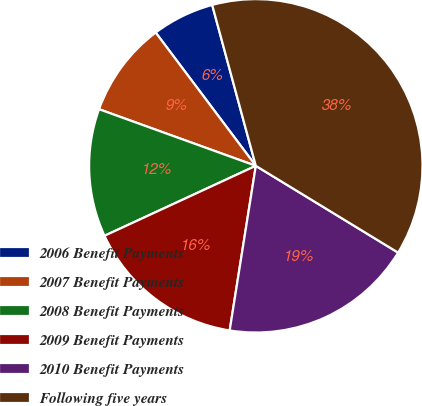Convert chart to OTSL. <chart><loc_0><loc_0><loc_500><loc_500><pie_chart><fcel>2006 Benefit Payments<fcel>2007 Benefit Payments<fcel>2008 Benefit Payments<fcel>2009 Benefit Payments<fcel>2010 Benefit Payments<fcel>Following five years<nl><fcel>6.04%<fcel>9.23%<fcel>12.41%<fcel>15.6%<fcel>18.79%<fcel>37.93%<nl></chart> 